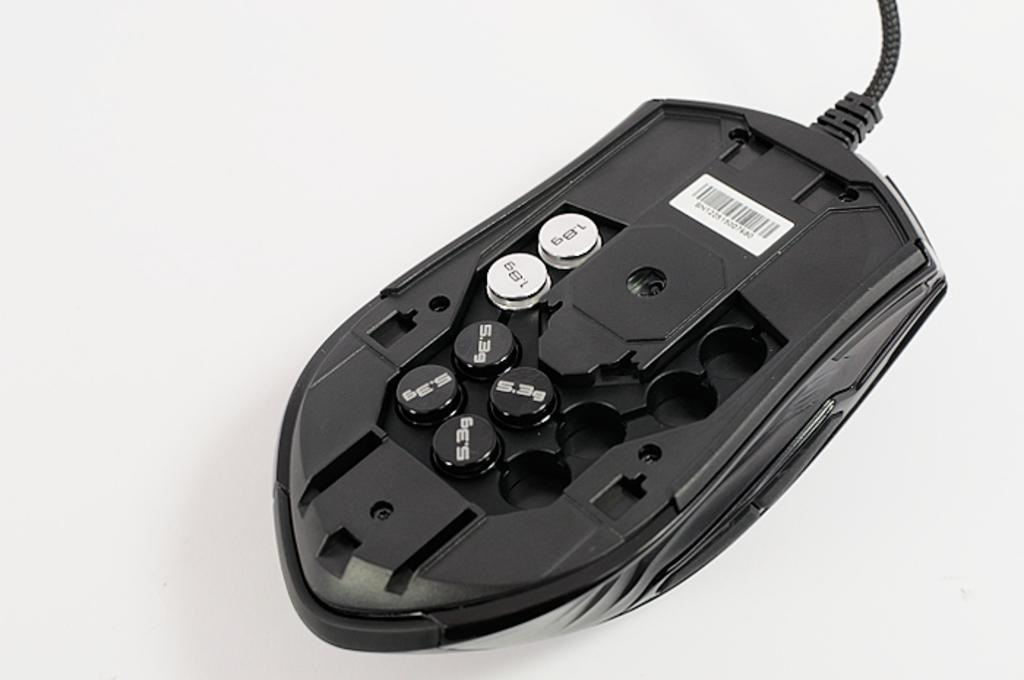What type of animal is in the image? There is a mouse in the image. How is the mouse positioned in the image? The mouse is in the back view. What color is the mouse in the image? The mouse is black in color. What type of toy can be seen in the image? There is no toy present in the image; it features a black mouse in the back view. What kind of berry is visible in the image? There is no berry present in the image. 